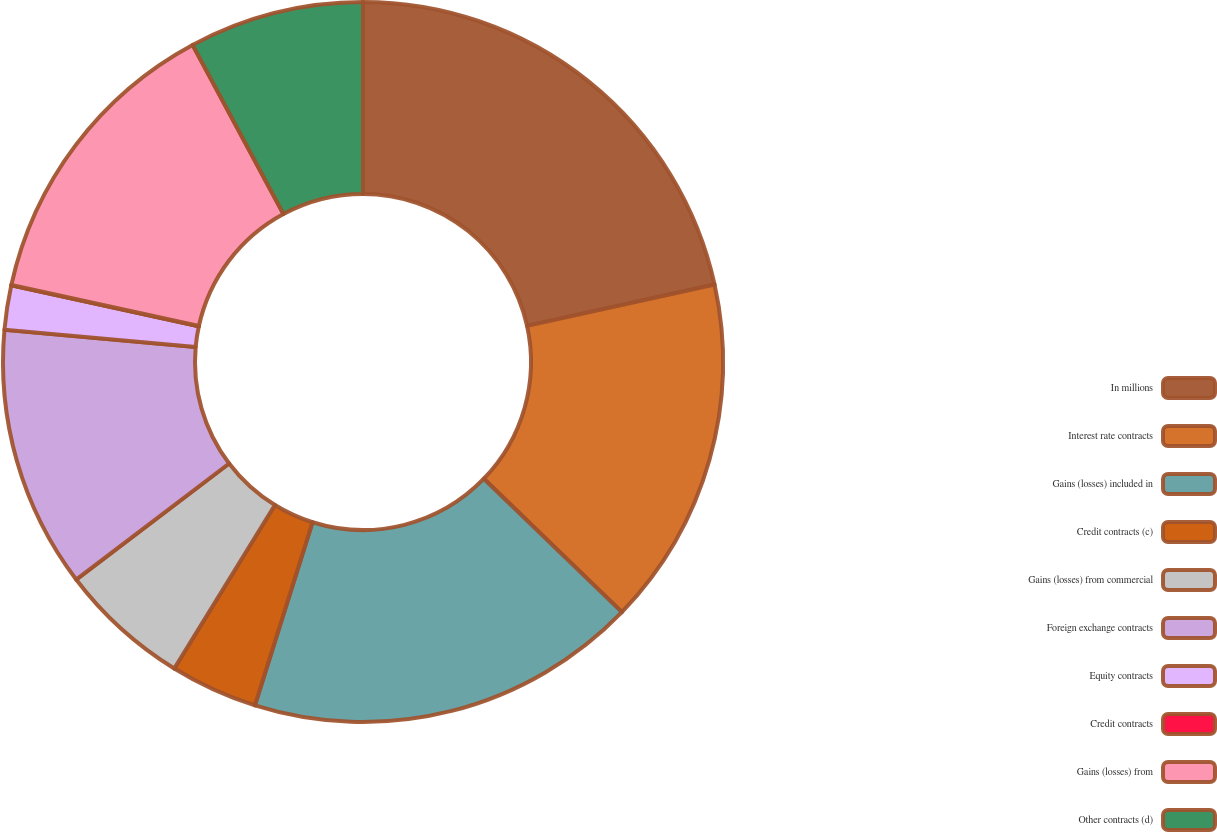<chart> <loc_0><loc_0><loc_500><loc_500><pie_chart><fcel>In millions<fcel>Interest rate contracts<fcel>Gains (losses) included in<fcel>Credit contracts (c)<fcel>Gains (losses) from commercial<fcel>Foreign exchange contracts<fcel>Equity contracts<fcel>Credit contracts<fcel>Gains (losses) from<fcel>Other contracts (d)<nl><fcel>21.55%<fcel>15.68%<fcel>17.63%<fcel>3.93%<fcel>5.89%<fcel>11.76%<fcel>1.98%<fcel>0.02%<fcel>13.72%<fcel>7.85%<nl></chart> 